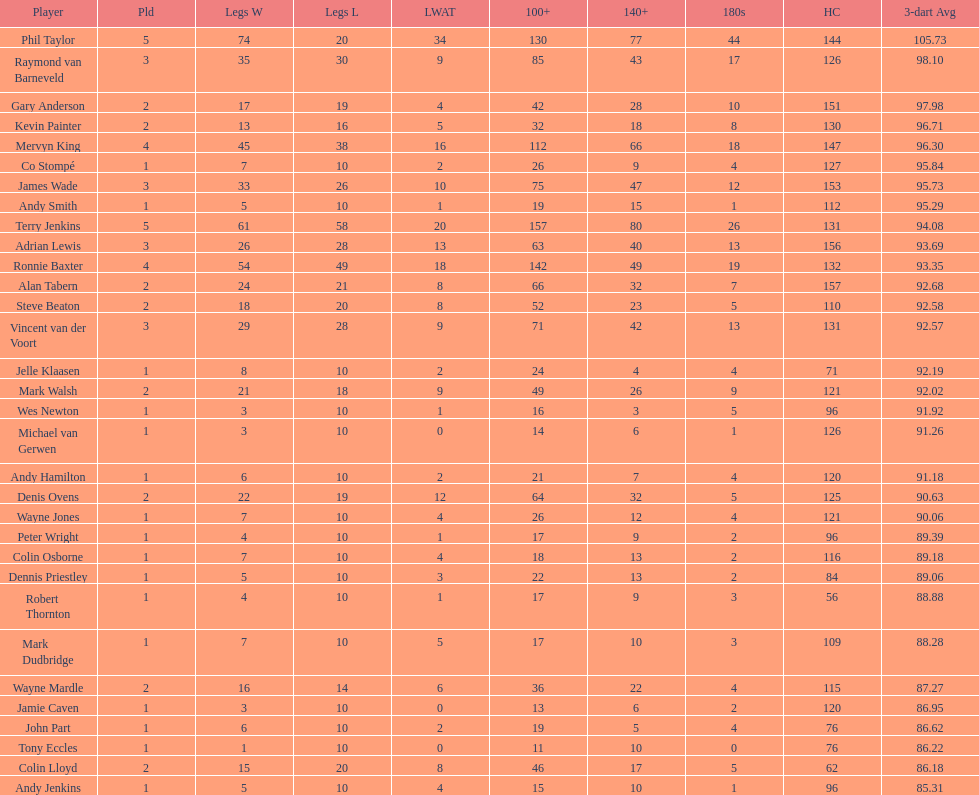List each of the players with a high checkout of 131. Terry Jenkins, Vincent van der Voort. 